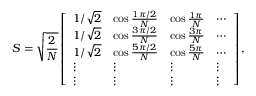Convert formula to latex. <formula><loc_0><loc_0><loc_500><loc_500>S = \sqrt { \frac { 2 } { N } } \left [ \begin{array} { l l l l } { 1 / \sqrt { 2 } } & { \cos \frac { 1 \pi / 2 } { N } } & { \cos \frac { 1 \pi } { N } } & { \cdots } \\ { 1 / \sqrt { 2 } } & { \cos \frac { 3 \pi / 2 } { N } } & { \cos \frac { 3 \pi } { N } } & { \cdots } \\ { 1 / \sqrt { 2 } } & { \cos \frac { 5 \pi / 2 } { N } } & { \cos \frac { 5 \pi } { N } } & { \cdots } \\ { \vdots } & { \vdots } & { \vdots } & { \vdots } \\ { \vdots } & { \vdots } & { \vdots } & { \vdots } \end{array} \right ] ,</formula> 